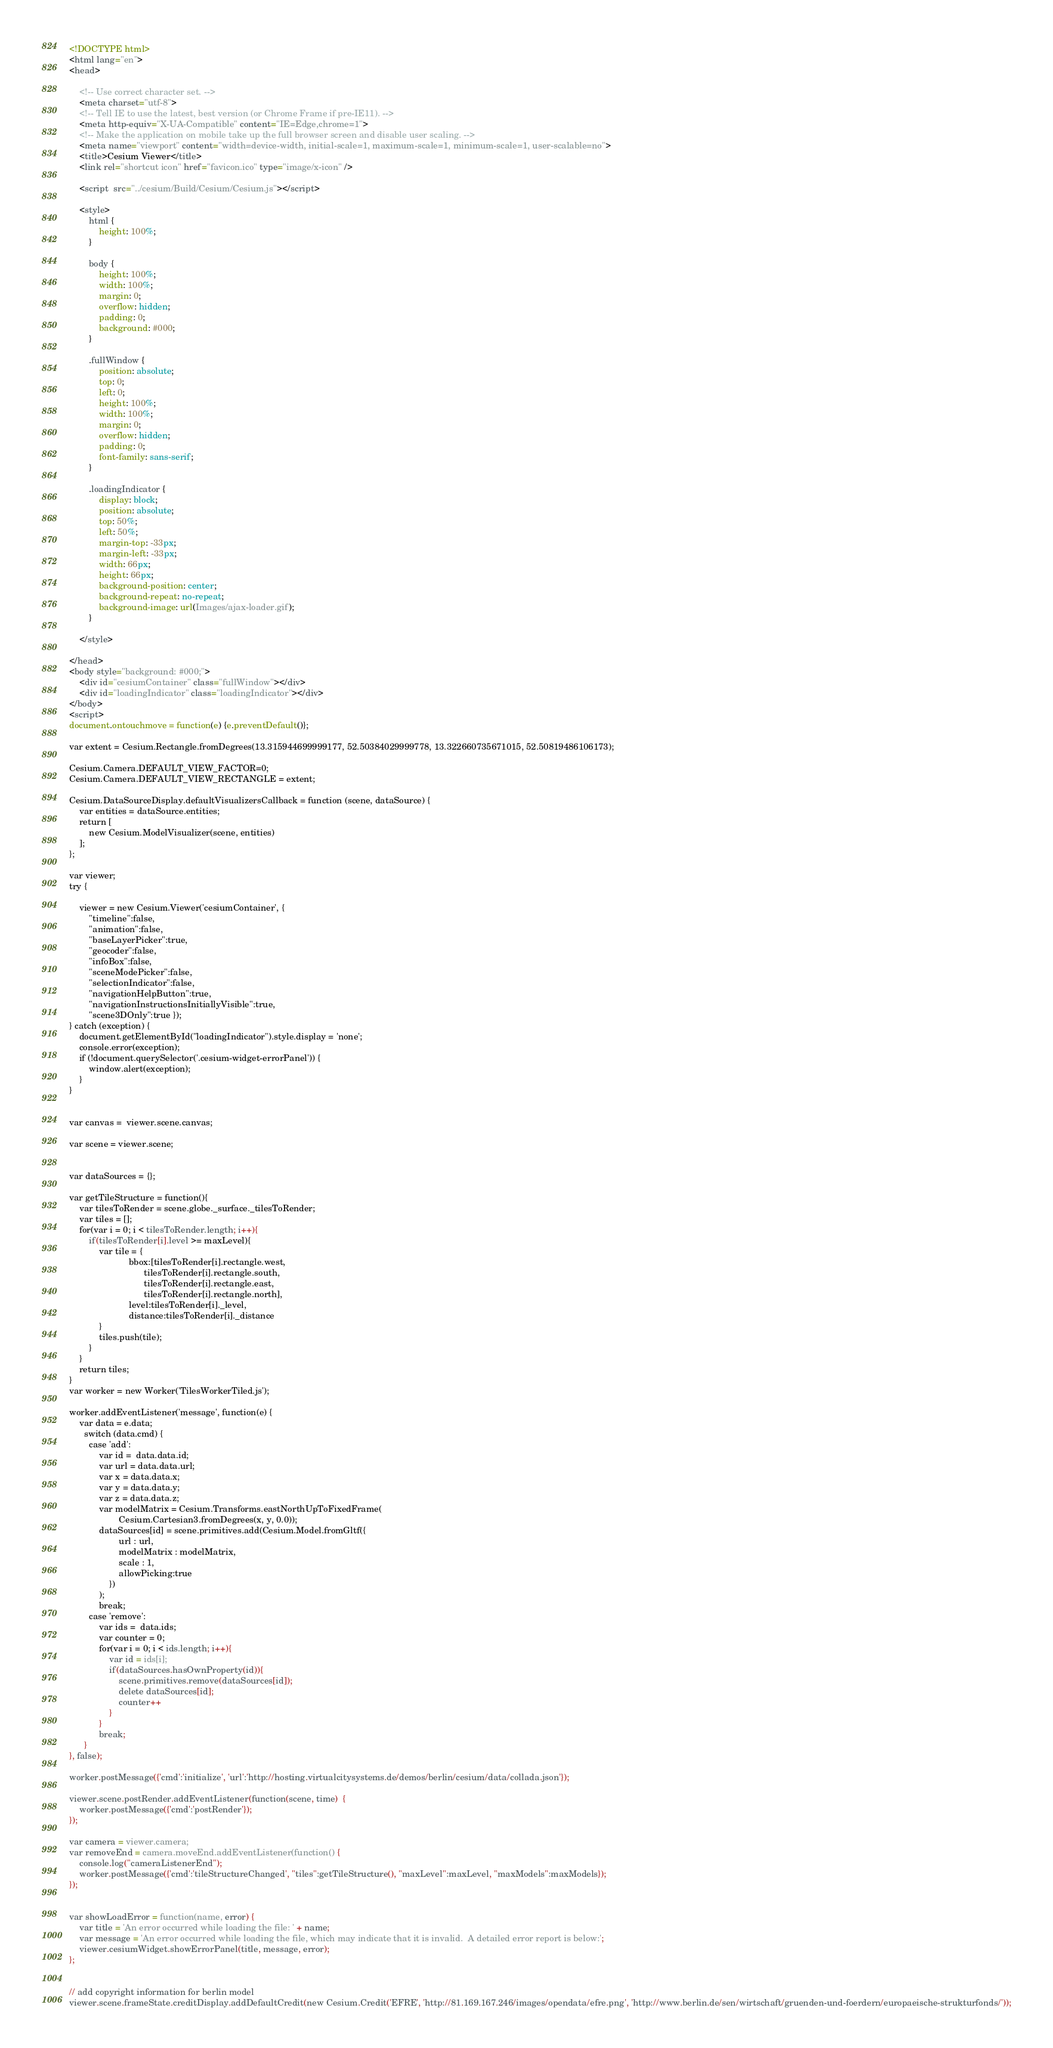Convert code to text. <code><loc_0><loc_0><loc_500><loc_500><_HTML_><!DOCTYPE html>
<html lang="en">
<head>

    <!-- Use correct character set. -->
    <meta charset="utf-8">
    <!-- Tell IE to use the latest, best version (or Chrome Frame if pre-IE11). -->
    <meta http-equiv="X-UA-Compatible" content="IE=Edge,chrome=1">
    <!-- Make the application on mobile take up the full browser screen and disable user scaling. -->
    <meta name="viewport" content="width=device-width, initial-scale=1, maximum-scale=1, minimum-scale=1, user-scalable=no">
    <title>Cesium Viewer</title>
    <link rel="shortcut icon" href="favicon.ico" type="image/x-icon" />
    
    <script  src="../cesium/Build/Cesium/Cesium.js"></script>

	<style>
		html {
		    height: 100%;
		}
		
		body {
		    height: 100%;
		    width: 100%;
		    margin: 0;
		    overflow: hidden;
		    padding: 0;
		    background: #000;
		}
		
		.fullWindow {
		    position: absolute;
		    top: 0;
		    left: 0;
		    height: 100%;
		    width: 100%;
		    margin: 0;
		    overflow: hidden;
		    padding: 0;
		    font-family: sans-serif;
		}
		
		.loadingIndicator {
		    display: block;
		    position: absolute;
		    top: 50%;
		    left: 50%;
		    margin-top: -33px;
		    margin-left: -33px;
		    width: 66px;
		    height: 66px;
		    background-position: center;
		    background-repeat: no-repeat;
		    background-image: url(Images/ajax-loader.gif);
		}
	
	</style>	
              
</head>
<body style="background: #000;">
    <div id="cesiumContainer" class="fullWindow"></div>
    <div id="loadingIndicator" class="loadingIndicator"></div>
</body>
<script>
document.ontouchmove = function(e) {e.preventDefault()};

var extent = Cesium.Rectangle.fromDegrees(13.315944699999177, 52.50384029999778, 13.322660735671015, 52.50819486106173);

Cesium.Camera.DEFAULT_VIEW_FACTOR=0;
Cesium.Camera.DEFAULT_VIEW_RECTANGLE = extent;

Cesium.DataSourceDisplay.defaultVisualizersCallback = function (scene, dataSource) {
    var entities = dataSource.entities;
    return [
        new Cesium.ModelVisualizer(scene, entities)
    ];
};

var viewer;
try {
    
	viewer = new Cesium.Viewer('cesiumContainer', {
		"timeline":false,
		"animation":false, 
		"baseLayerPicker":true,
		"geocoder":false,									
		"infoBox":false,
		"sceneModePicker":false,
		"selectionIndicator":false,
		"navigationHelpButton":true,
		"navigationInstructionsInitiallyVisible":true,
		"scene3DOnly":true });		 
} catch (exception) {
	document.getElementById("loadingIndicator").style.display = 'none';    
    console.error(exception);
    if (!document.querySelector('.cesium-widget-errorPanel')) {
        window.alert(exception);
    }
}


var canvas =  viewer.scene.canvas;

var scene = viewer.scene;


var dataSources = {};

var getTileStructure = function(){    	
	var tilesToRender = scene.globe._surface._tilesToRender;
	var tiles = [];
	for(var i = 0; i < tilesToRender.length; i++){
		if(tilesToRender[i].level >= maxLevel){
    		var tile = {
    					bbox:[tilesToRender[i].rectangle.west,
    					      tilesToRender[i].rectangle.south,
    					      tilesToRender[i].rectangle.east,
    					      tilesToRender[i].rectangle.north], 
    					level:tilesToRender[i]._level, 
    					distance:tilesToRender[i]._distance    		
    		}
    		tiles.push(tile);
		}
	}    	
	return tiles;
}
var worker = new Worker('TilesWorkerTiled.js');

worker.addEventListener('message', function(e) {
	var data = e.data;
	  switch (data.cmd) {
	    case 'add':
	    	var id =  data.data.id;
	    	var url = data.data.url;
	    	var x = data.data.x;
	    	var y = data.data.y;
	    	var z = data.data.z;
    		var modelMatrix = Cesium.Transforms.eastNorthUpToFixedFrame(
        		    Cesium.Cartesian3.fromDegrees(x, y, 0.0));
    		dataSources[id] = scene.primitives.add(Cesium.Model.fromGltf({
    		    	url : url,
    		    	modelMatrix : modelMatrix,		 
    		    	scale : 1, 
					allowPicking:true
    			})				
			);
	    	break;
	    case 'remove':
	    	var ids =  data.ids;
	    	var counter = 0;
	    	for(var i = 0; i < ids.length; i++){
	    		var id = ids[i];
    	    	if(dataSources.hasOwnProperty(id)){
    	    		scene.primitives.remove(dataSources[id]);
    	    		delete dataSources[id];
    	    		counter++
    	    	}
	  		}
	    	break;
	  }    
}, false);
   
worker.postMessage({'cmd':'initialize', 'url':'http://hosting.virtualcitysystems.de/demos/berlin/cesium/data/collada.json'});

viewer.scene.postRender.addEventListener(function(scene, time)  {
	worker.postMessage({'cmd':'postRender'});
});

var camera = viewer.camera;
var removeEnd = camera.moveEnd.addEventListener(function() {
	console.log("cameraListenerEnd");
	worker.postMessage({'cmd':'tileStructureChanged', "tiles":getTileStructure(), "maxLevel":maxLevel, "maxModels":maxModels});
});


var showLoadError = function(name, error) {
    var title = 'An error occurred while loading the file: ' + name;
    var message = 'An error occurred while loading the file, which may indicate that it is invalid.  A detailed error report is below:';
    viewer.cesiumWidget.showErrorPanel(title, message, error);
};


// add copyright information for berlin model
viewer.scene.frameState.creditDisplay.addDefaultCredit(new Cesium.Credit('EFRE', 'http://81.169.167.246/images/opendata/efre.png', 'http://www.berlin.de/sen/wirtschaft/gruenden-und-foerdern/europaeische-strukturfonds/'));</code> 